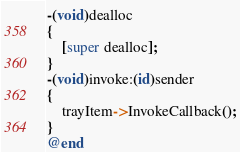Convert code to text. <code><loc_0><loc_0><loc_500><loc_500><_ObjectiveC_>-(void)dealloc
{
    [super dealloc];
}
-(void)invoke:(id)sender
{
    trayItem->InvokeCallback();
}
@end
</code> 